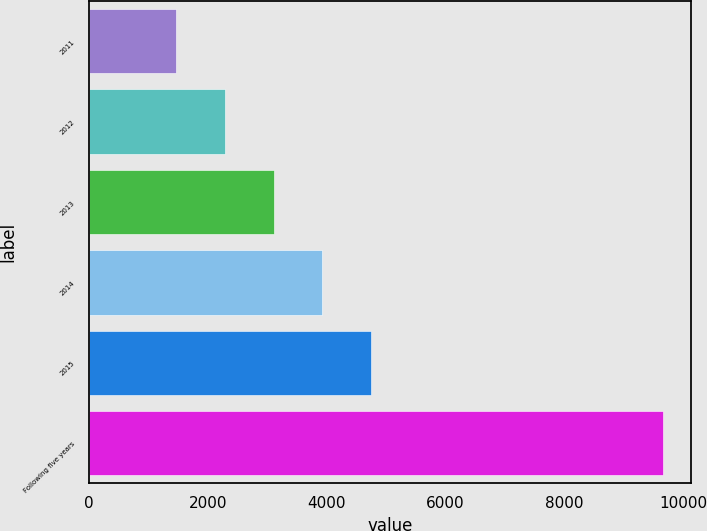Convert chart to OTSL. <chart><loc_0><loc_0><loc_500><loc_500><bar_chart><fcel>2011<fcel>2012<fcel>2013<fcel>2014<fcel>2015<fcel>Following five years<nl><fcel>1469<fcel>2287.9<fcel>3106.8<fcel>3925.7<fcel>4744.6<fcel>9658<nl></chart> 